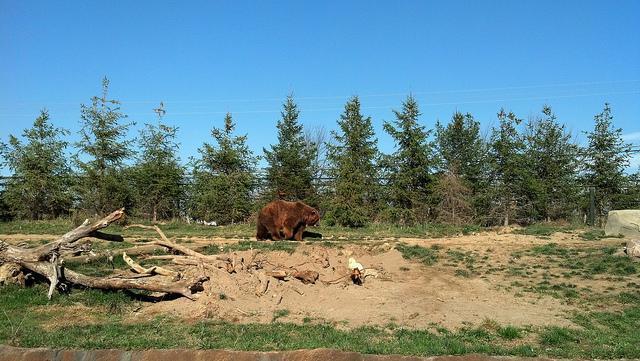How many black cars are in the picture?
Give a very brief answer. 0. 